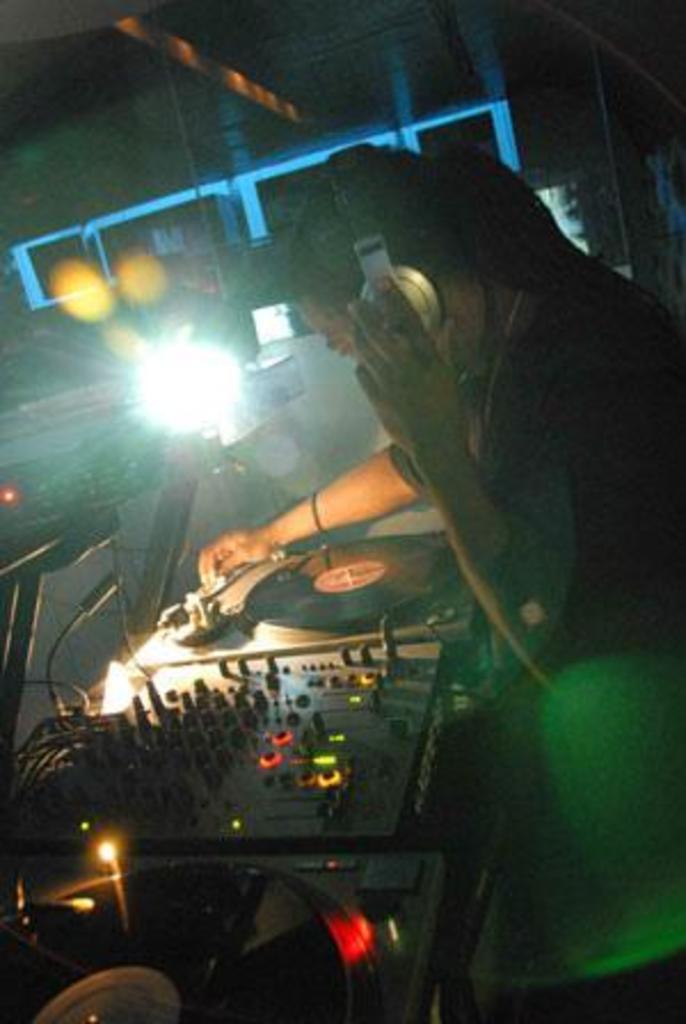Can you describe this image briefly? In this picture we can see a man, he wore a headset, in front of him we can find few musical instruments, in the background we can see lights. 